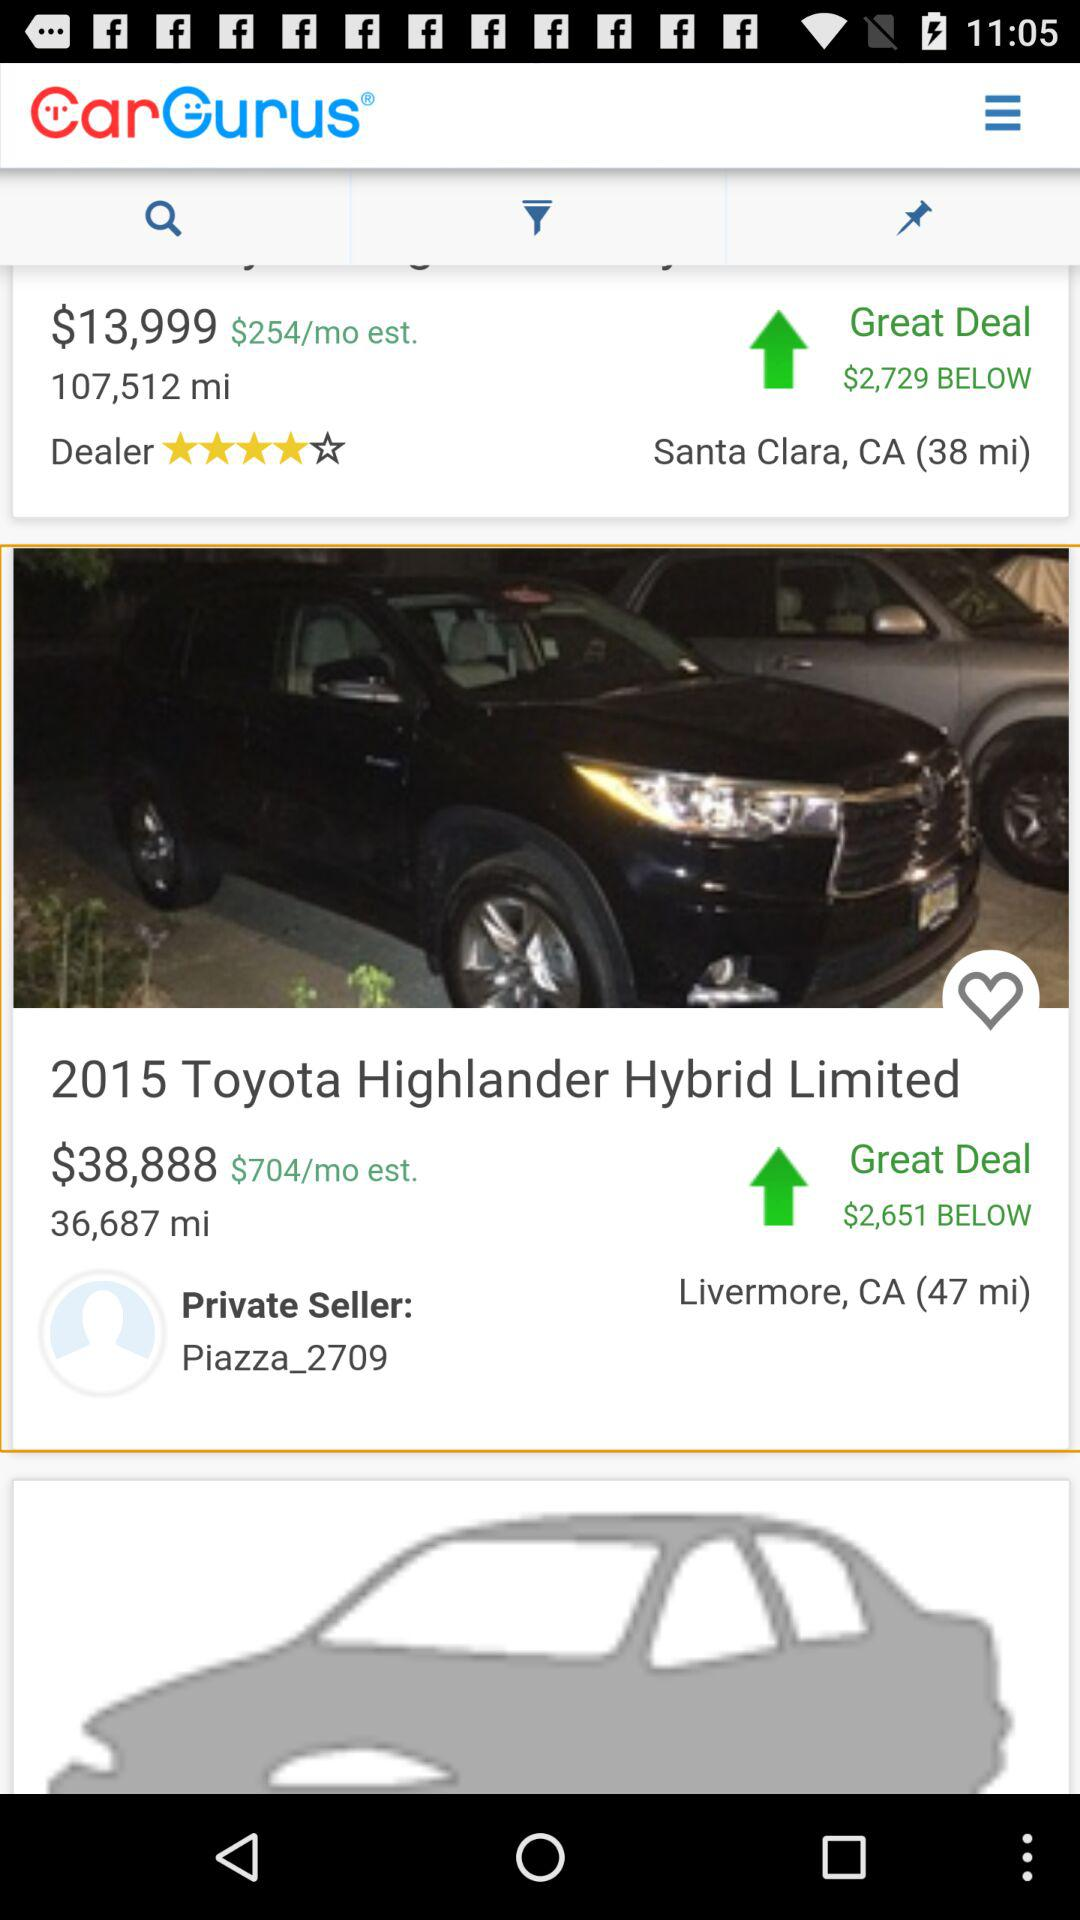What is the name of the application? The name of the application "Car Gurus". 